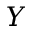Convert formula to latex. <formula><loc_0><loc_0><loc_500><loc_500>Y</formula> 